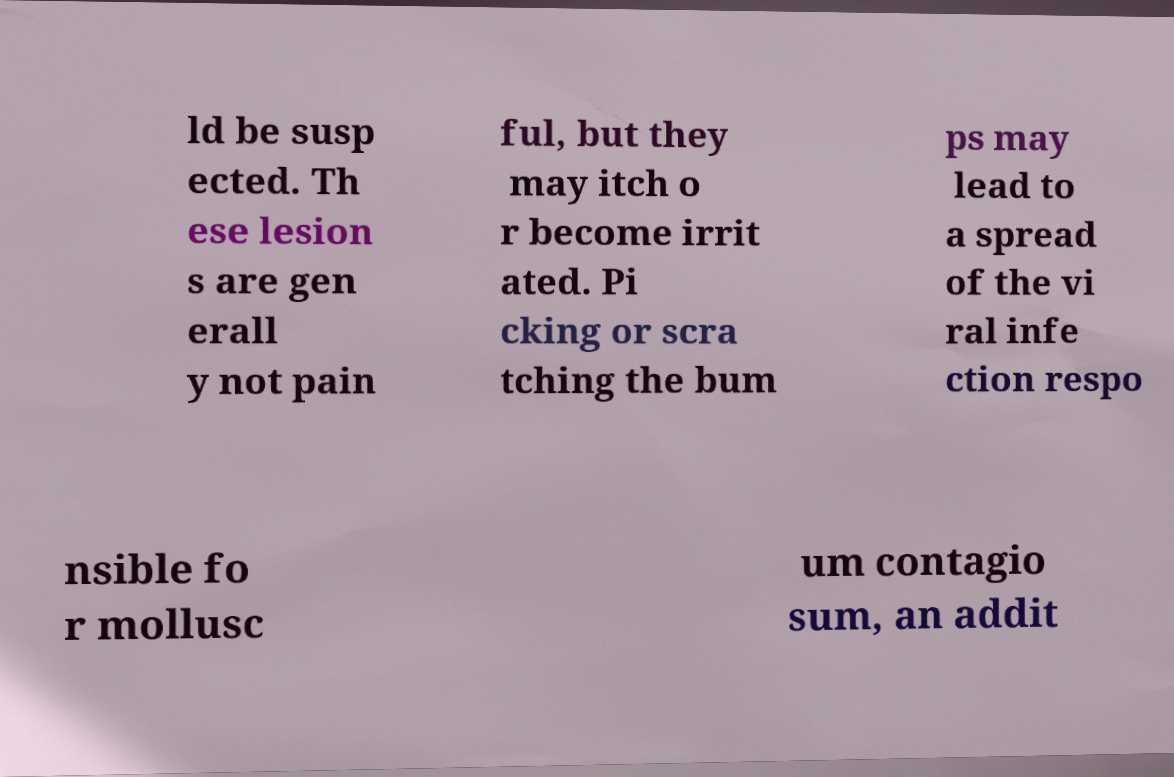Can you accurately transcribe the text from the provided image for me? ld be susp ected. Th ese lesion s are gen erall y not pain ful, but they may itch o r become irrit ated. Pi cking or scra tching the bum ps may lead to a spread of the vi ral infe ction respo nsible fo r mollusc um contagio sum, an addit 